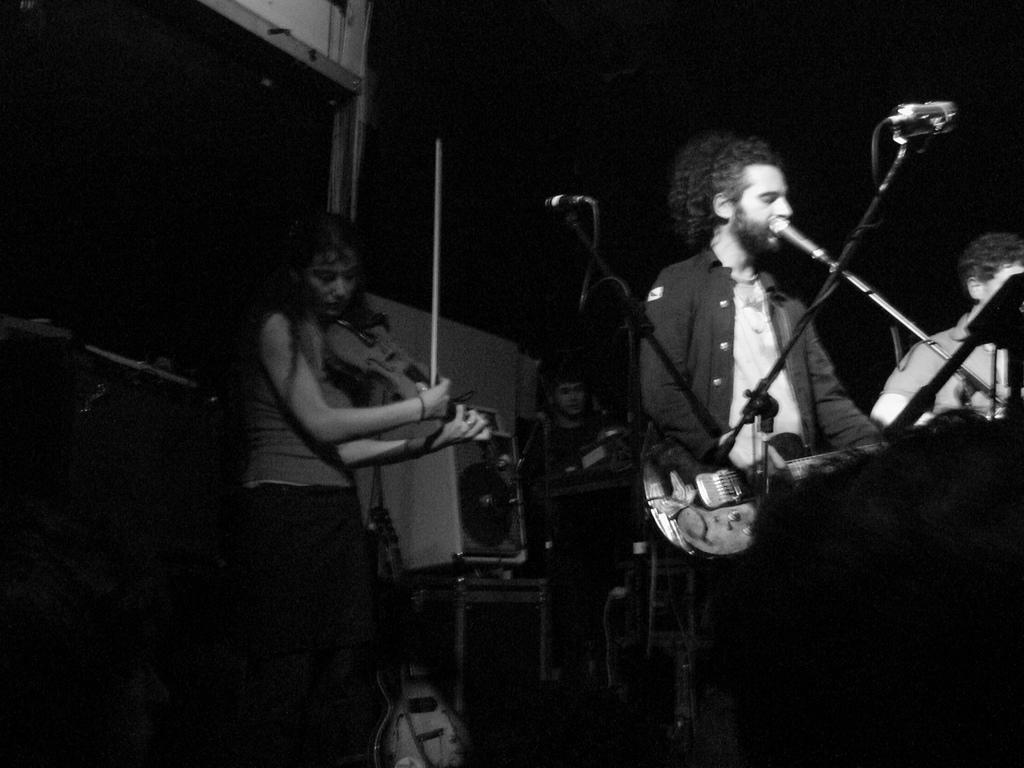Can you describe this image briefly? There are three members standing in the picture. Everyone is having a microphone and stands in front of them. There is a girl who is playing the violin and a man playing a guitar. There are some equipment in the background. 